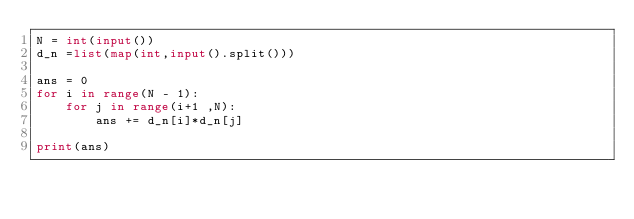Convert code to text. <code><loc_0><loc_0><loc_500><loc_500><_Python_>N = int(input())
d_n =list(map(int,input().split()))

ans = 0
for i in range(N - 1):
    for j in range(i+1 ,N):
        ans += d_n[i]*d_n[j]    

print(ans)</code> 